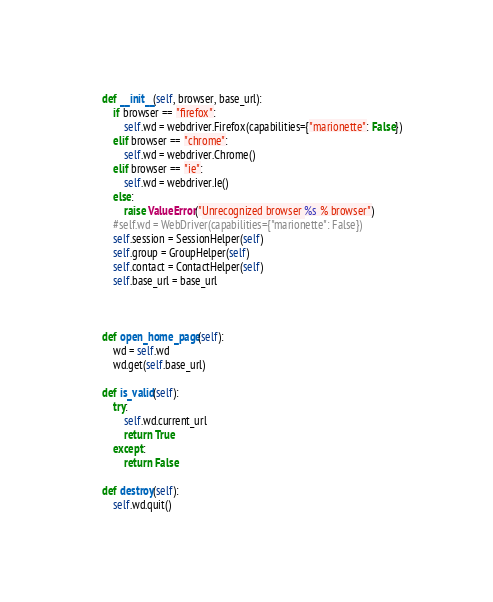Convert code to text. <code><loc_0><loc_0><loc_500><loc_500><_Python_>
    def __init__(self, browser, base_url):
        if browser == "firefox":
            self.wd = webdriver.Firefox(capabilities={"marionette": False})
        elif browser == "chrome":
            self.wd = webdriver.Chrome()
        elif browser == "ie":
            self.wd = webdriver.Ie()
        else:
            raise ValueError("Unrecognized browser %s % browser")
        #self.wd = WebDriver(capabilities={"marionette": False})
        self.session = SessionHelper(self)
        self.group = GroupHelper(self)
        self.contact = ContactHelper(self)
        self.base_url = base_url



    def open_home_page(self):
        wd = self.wd
        wd.get(self.base_url)

    def is_valid(self):
        try:
            self.wd.current_url
            return True
        except:
            return False

    def destroy(self):
        self.wd.quit()</code> 